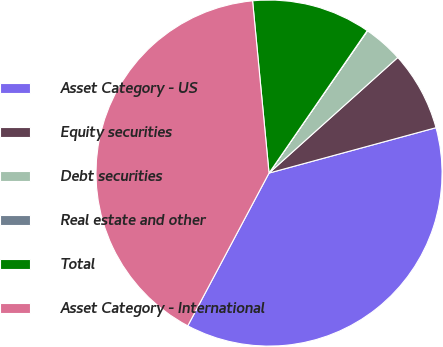Convert chart. <chart><loc_0><loc_0><loc_500><loc_500><pie_chart><fcel>Asset Category - US<fcel>Equity securities<fcel>Debt securities<fcel>Real estate and other<fcel>Total<fcel>Asset Category - International<nl><fcel>37.0%<fcel>7.42%<fcel>3.72%<fcel>0.03%<fcel>11.12%<fcel>40.7%<nl></chart> 